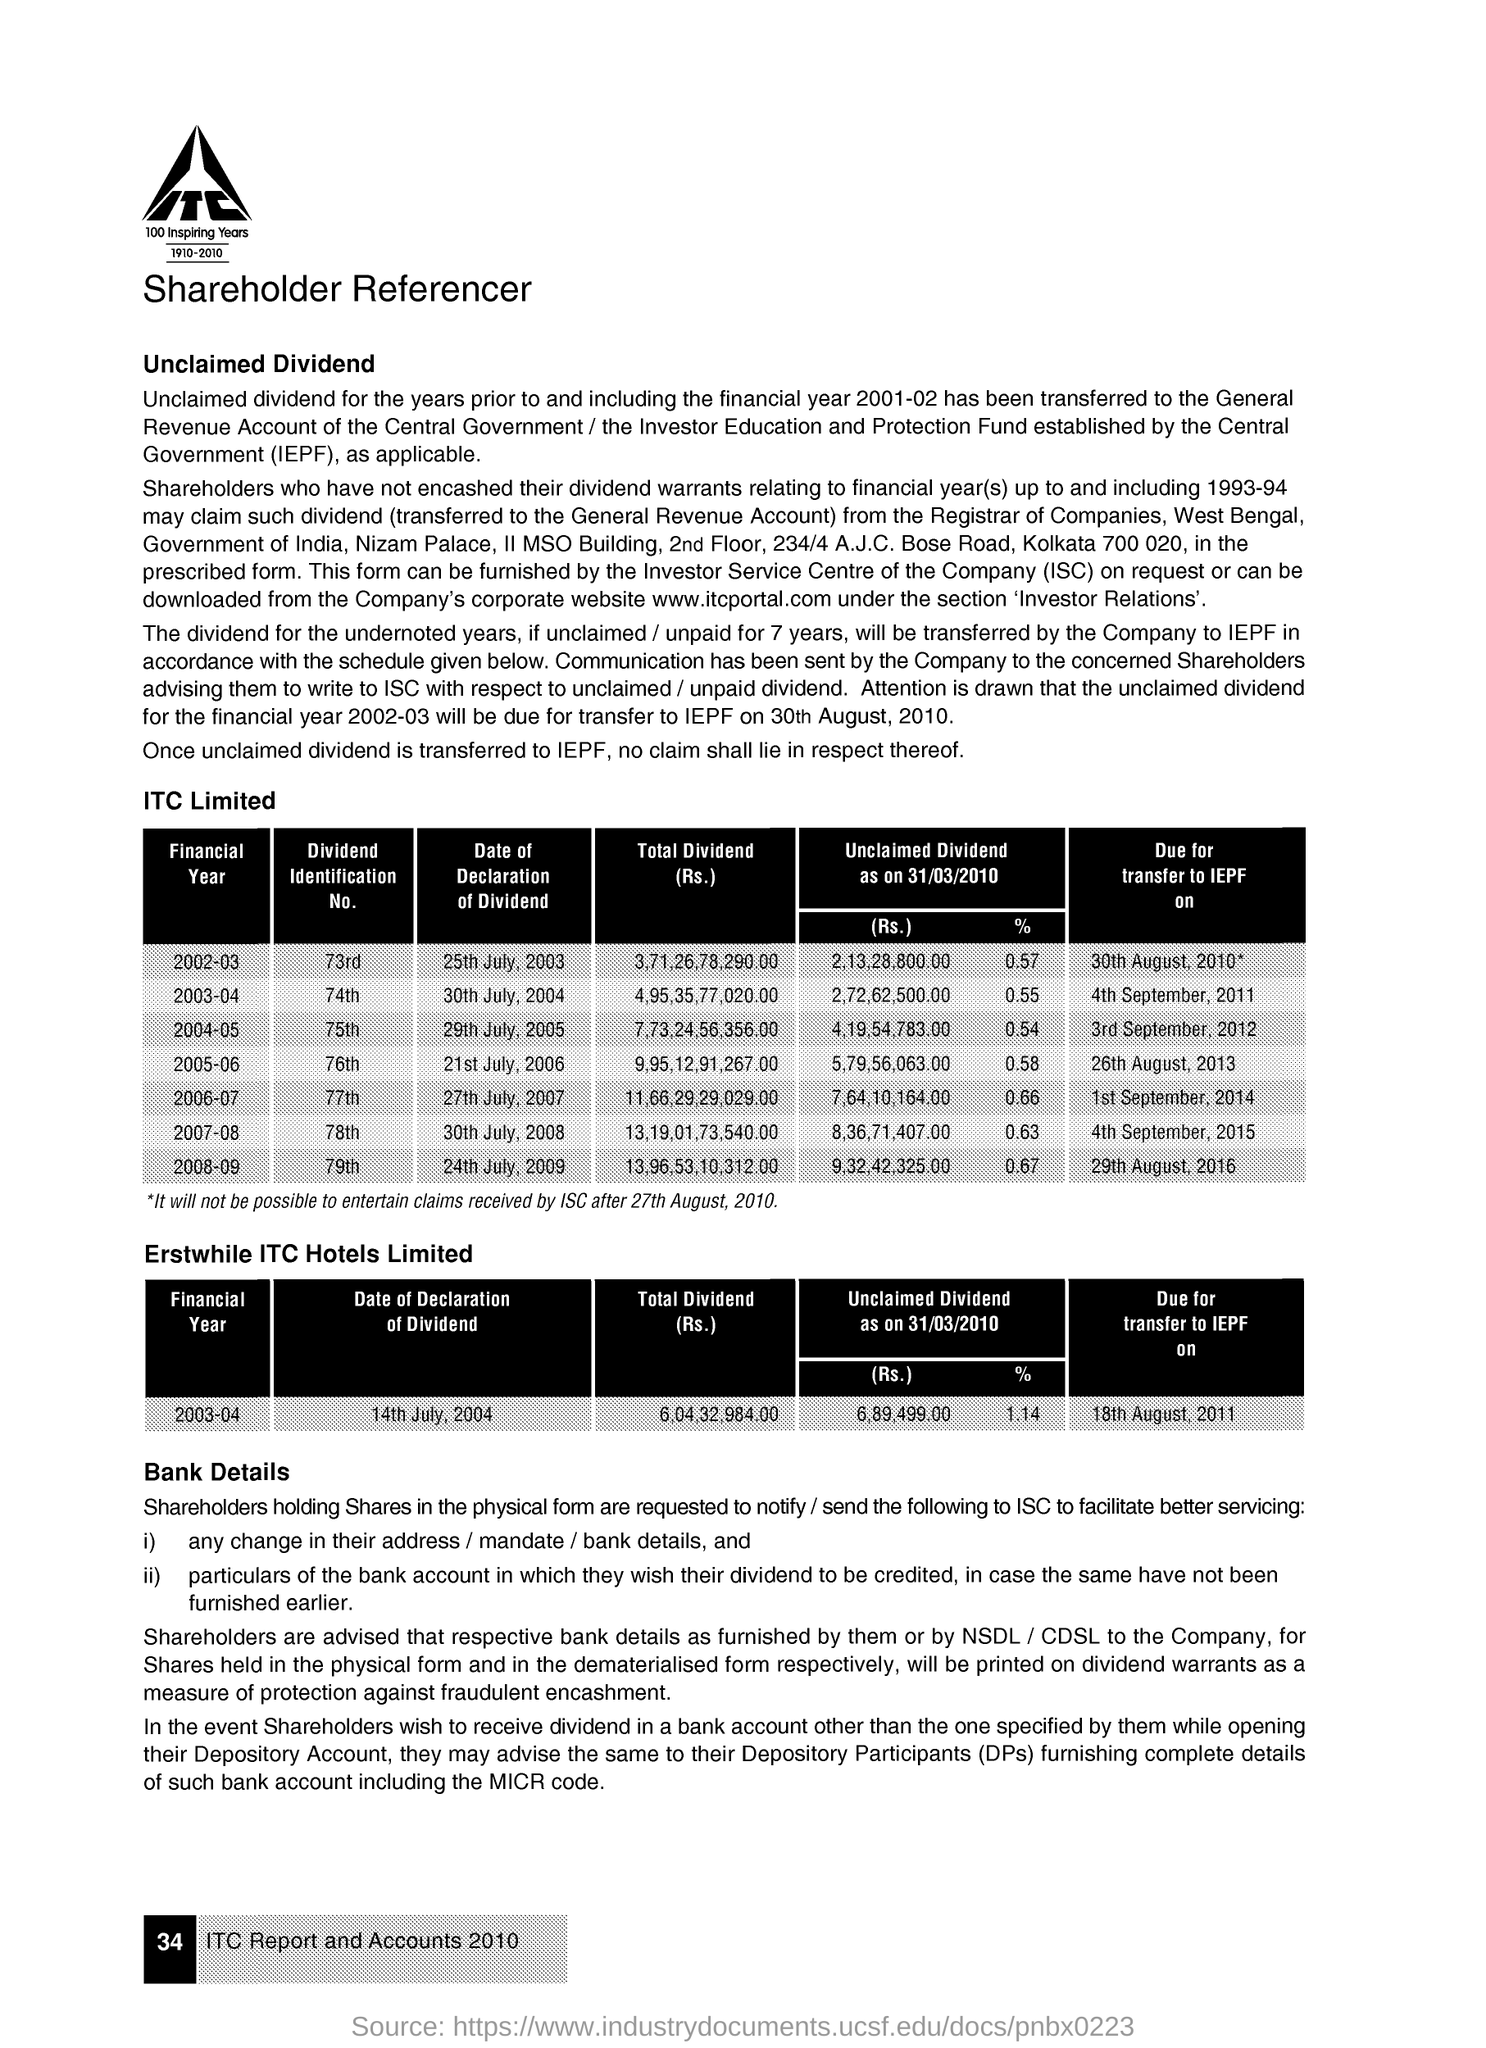Give some essential details in this illustration. The dividend identification number for the financial year 2007-2008 is 78. The dividend identification number for the financial year 2005-06 is 76th. The dividend identification number for the financial year 2004-2005 was 75. The dividend identification number for the financial year 2003-04 is 74th. The dividend identification number for the financial year 2002-03 is 73rd. 